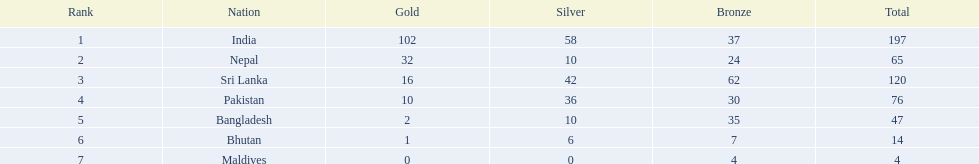What nations took part in 1999 south asian games? India, Nepal, Sri Lanka, Pakistan, Bangladesh, Bhutan, Maldives. Of those who earned gold medals? India, Nepal, Sri Lanka, Pakistan, Bangladesh, Bhutan. Which nation didn't earn any gold medals? Maldives. 